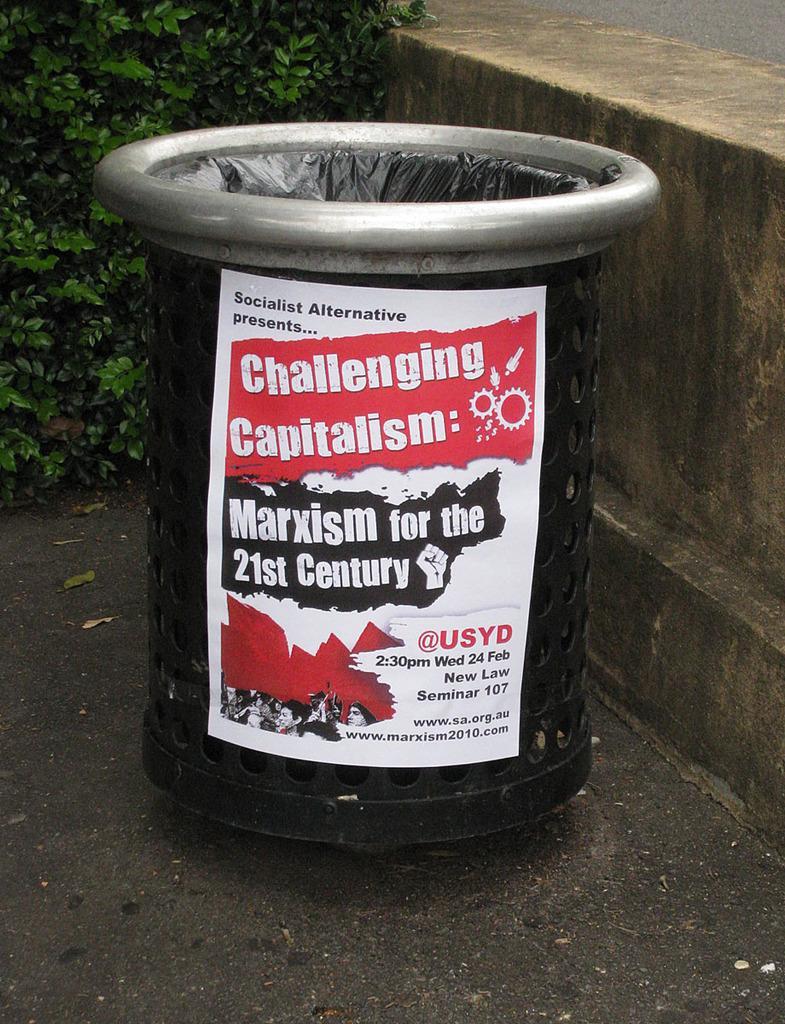Can you describe this image briefly? In the foreground of this image, there is a poster to a dustbin like an object which is on the road. In the background, there is a tiny wall and plants. 